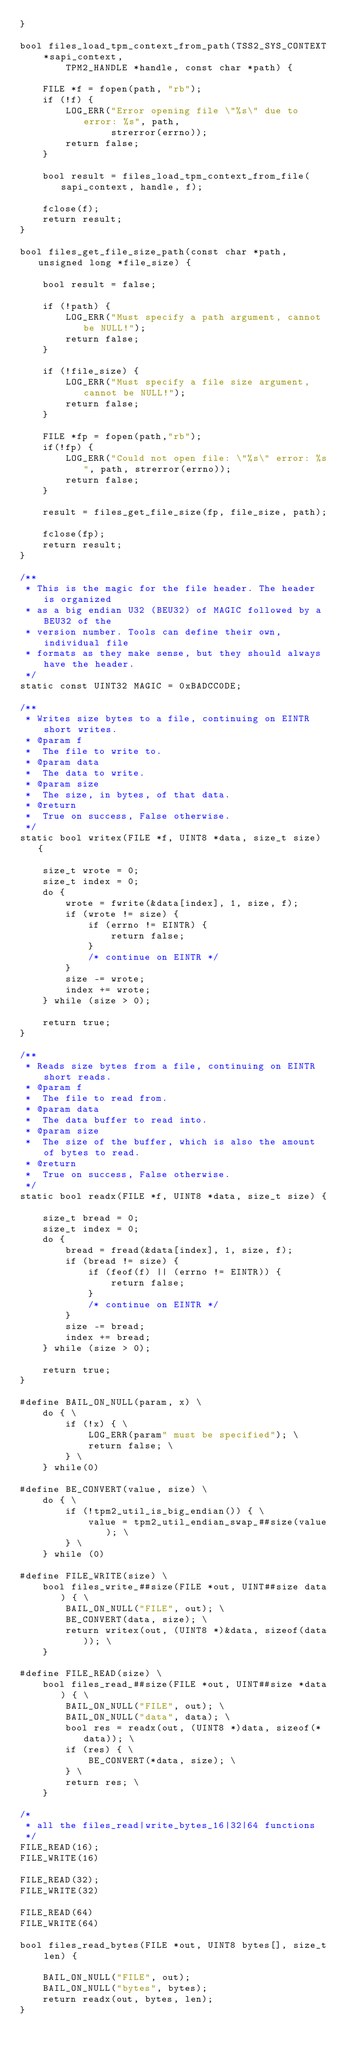Convert code to text. <code><loc_0><loc_0><loc_500><loc_500><_C_>}

bool files_load_tpm_context_from_path(TSS2_SYS_CONTEXT *sapi_context,
        TPM2_HANDLE *handle, const char *path) {

    FILE *f = fopen(path, "rb");
    if (!f) {
        LOG_ERR("Error opening file \"%s\" due to error: %s", path,
                strerror(errno));
        return false;
    }

    bool result = files_load_tpm_context_from_file(sapi_context, handle, f);

    fclose(f);
    return result;
}

bool files_get_file_size_path(const char *path, unsigned long *file_size) {

    bool result = false;

    if (!path) {
        LOG_ERR("Must specify a path argument, cannot be NULL!");
        return false;
    }

    if (!file_size) {
        LOG_ERR("Must specify a file size argument, cannot be NULL!");
        return false;
    }

    FILE *fp = fopen(path,"rb");
    if(!fp) {
        LOG_ERR("Could not open file: \"%s\" error: %s", path, strerror(errno));
        return false;
    }

    result = files_get_file_size(fp, file_size, path);

    fclose(fp);
    return result;
}

/**
 * This is the magic for the file header. The header is organized
 * as a big endian U32 (BEU32) of MAGIC followed by a BEU32 of the
 * version number. Tools can define their own, individual file
 * formats as they make sense, but they should always have the header.
 */
static const UINT32 MAGIC = 0xBADCC0DE;

/**
 * Writes size bytes to a file, continuing on EINTR short writes.
 * @param f
 *  The file to write to.
 * @param data
 *  The data to write.
 * @param size
 *  The size, in bytes, of that data.
 * @return
 *  True on success, False otherwise.
 */
static bool writex(FILE *f, UINT8 *data, size_t size) {

    size_t wrote = 0;
    size_t index = 0;
    do {
        wrote = fwrite(&data[index], 1, size, f);
        if (wrote != size) {
            if (errno != EINTR) {
                return false;
            }
            /* continue on EINTR */
        }
        size -= wrote;
        index += wrote;
    } while (size > 0);

    return true;
}

/**
 * Reads size bytes from a file, continuing on EINTR short reads.
 * @param f
 *  The file to read from.
 * @param data
 *  The data buffer to read into.
 * @param size
 *  The size of the buffer, which is also the amount of bytes to read.
 * @return
 *  True on success, False otherwise.
 */
static bool readx(FILE *f, UINT8 *data, size_t size) {

    size_t bread = 0;
    size_t index = 0;
    do {
        bread = fread(&data[index], 1, size, f);
        if (bread != size) {
            if (feof(f) || (errno != EINTR)) {
                return false;
            }
            /* continue on EINTR */
        }
        size -= bread;
        index += bread;
    } while (size > 0);

    return true;
}

#define BAIL_ON_NULL(param, x) \
    do { \
        if (!x) { \
            LOG_ERR(param" must be specified"); \
            return false; \
        } \
    } while(0)

#define BE_CONVERT(value, size) \
    do { \
        if (!tpm2_util_is_big_endian()) { \
            value = tpm2_util_endian_swap_##size(value); \
        } \
    } while (0)

#define FILE_WRITE(size) \
    bool files_write_##size(FILE *out, UINT##size data) { \
        BAIL_ON_NULL("FILE", out); \
        BE_CONVERT(data, size); \
        return writex(out, (UINT8 *)&data, sizeof(data)); \
    }

#define FILE_READ(size) \
    bool files_read_##size(FILE *out, UINT##size *data) { \
	    BAIL_ON_NULL("FILE", out); \
	    BAIL_ON_NULL("data", data); \
        bool res = readx(out, (UINT8 *)data, sizeof(*data)); \
        if (res) { \
            BE_CONVERT(*data, size); \
        } \
        return res; \
    }

/*
 * all the files_read|write_bytes_16|32|64 functions
 */
FILE_READ(16);
FILE_WRITE(16)

FILE_READ(32);
FILE_WRITE(32)

FILE_READ(64)
FILE_WRITE(64)

bool files_read_bytes(FILE *out, UINT8 bytes[], size_t len) {

    BAIL_ON_NULL("FILE", out);
    BAIL_ON_NULL("bytes", bytes);
    return readx(out, bytes, len);
}
</code> 